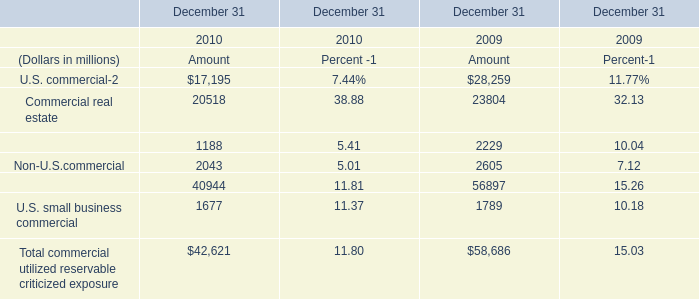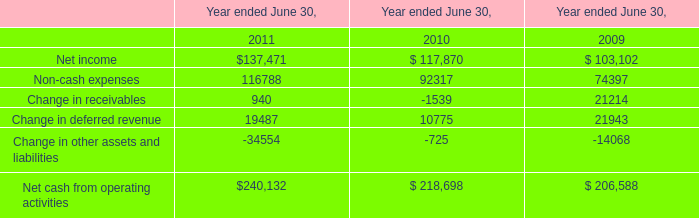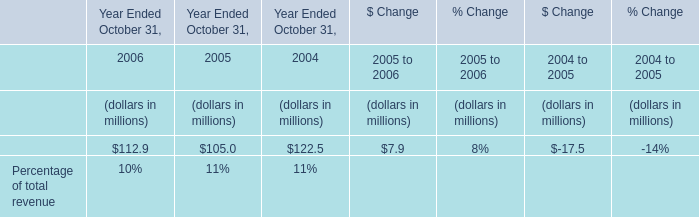What's the average of the Non-U.S.commercial in the years where Change in other assets and liabilities is greater than -15000? (in million) 
Computations: ((2043 + 2605) / 2)
Answer: 2324.0. 